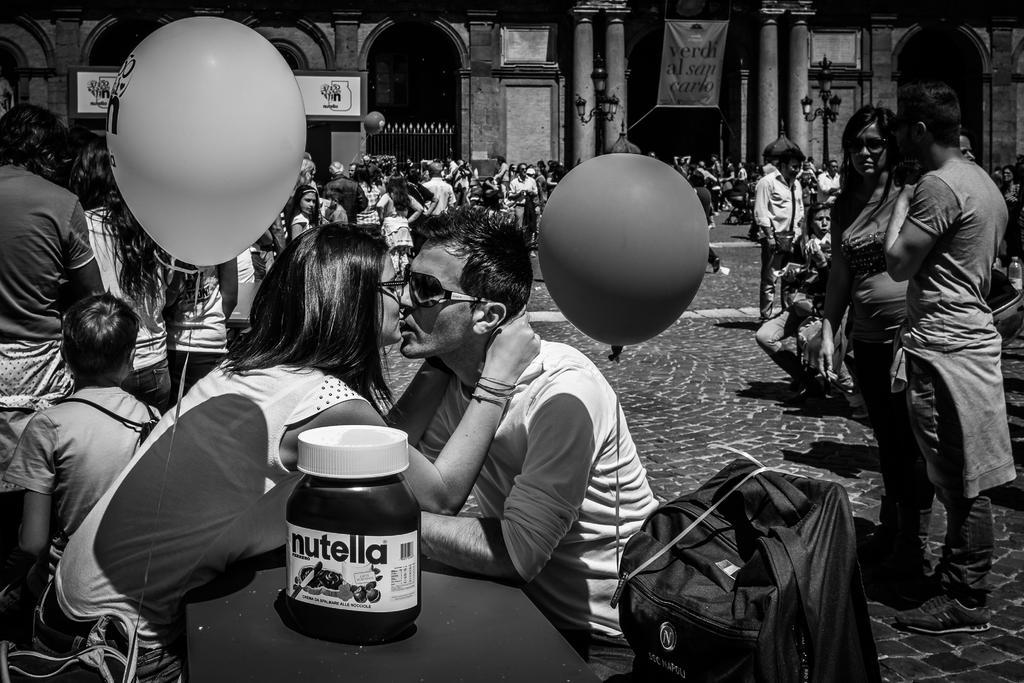Can you describe this image briefly? This black and white picture is clicked on the road. There are a few people sitting on the chairs and many standing. In the foreground there is a man and a woman sitting on the chairs. In between them there is a table. There is a bottle on the table. There is a bag beside the man. They are kissing each other. In the foreground there are balloons. In the background there is a building. There are banners and boards to the building. In front of the building there are street light poles. 